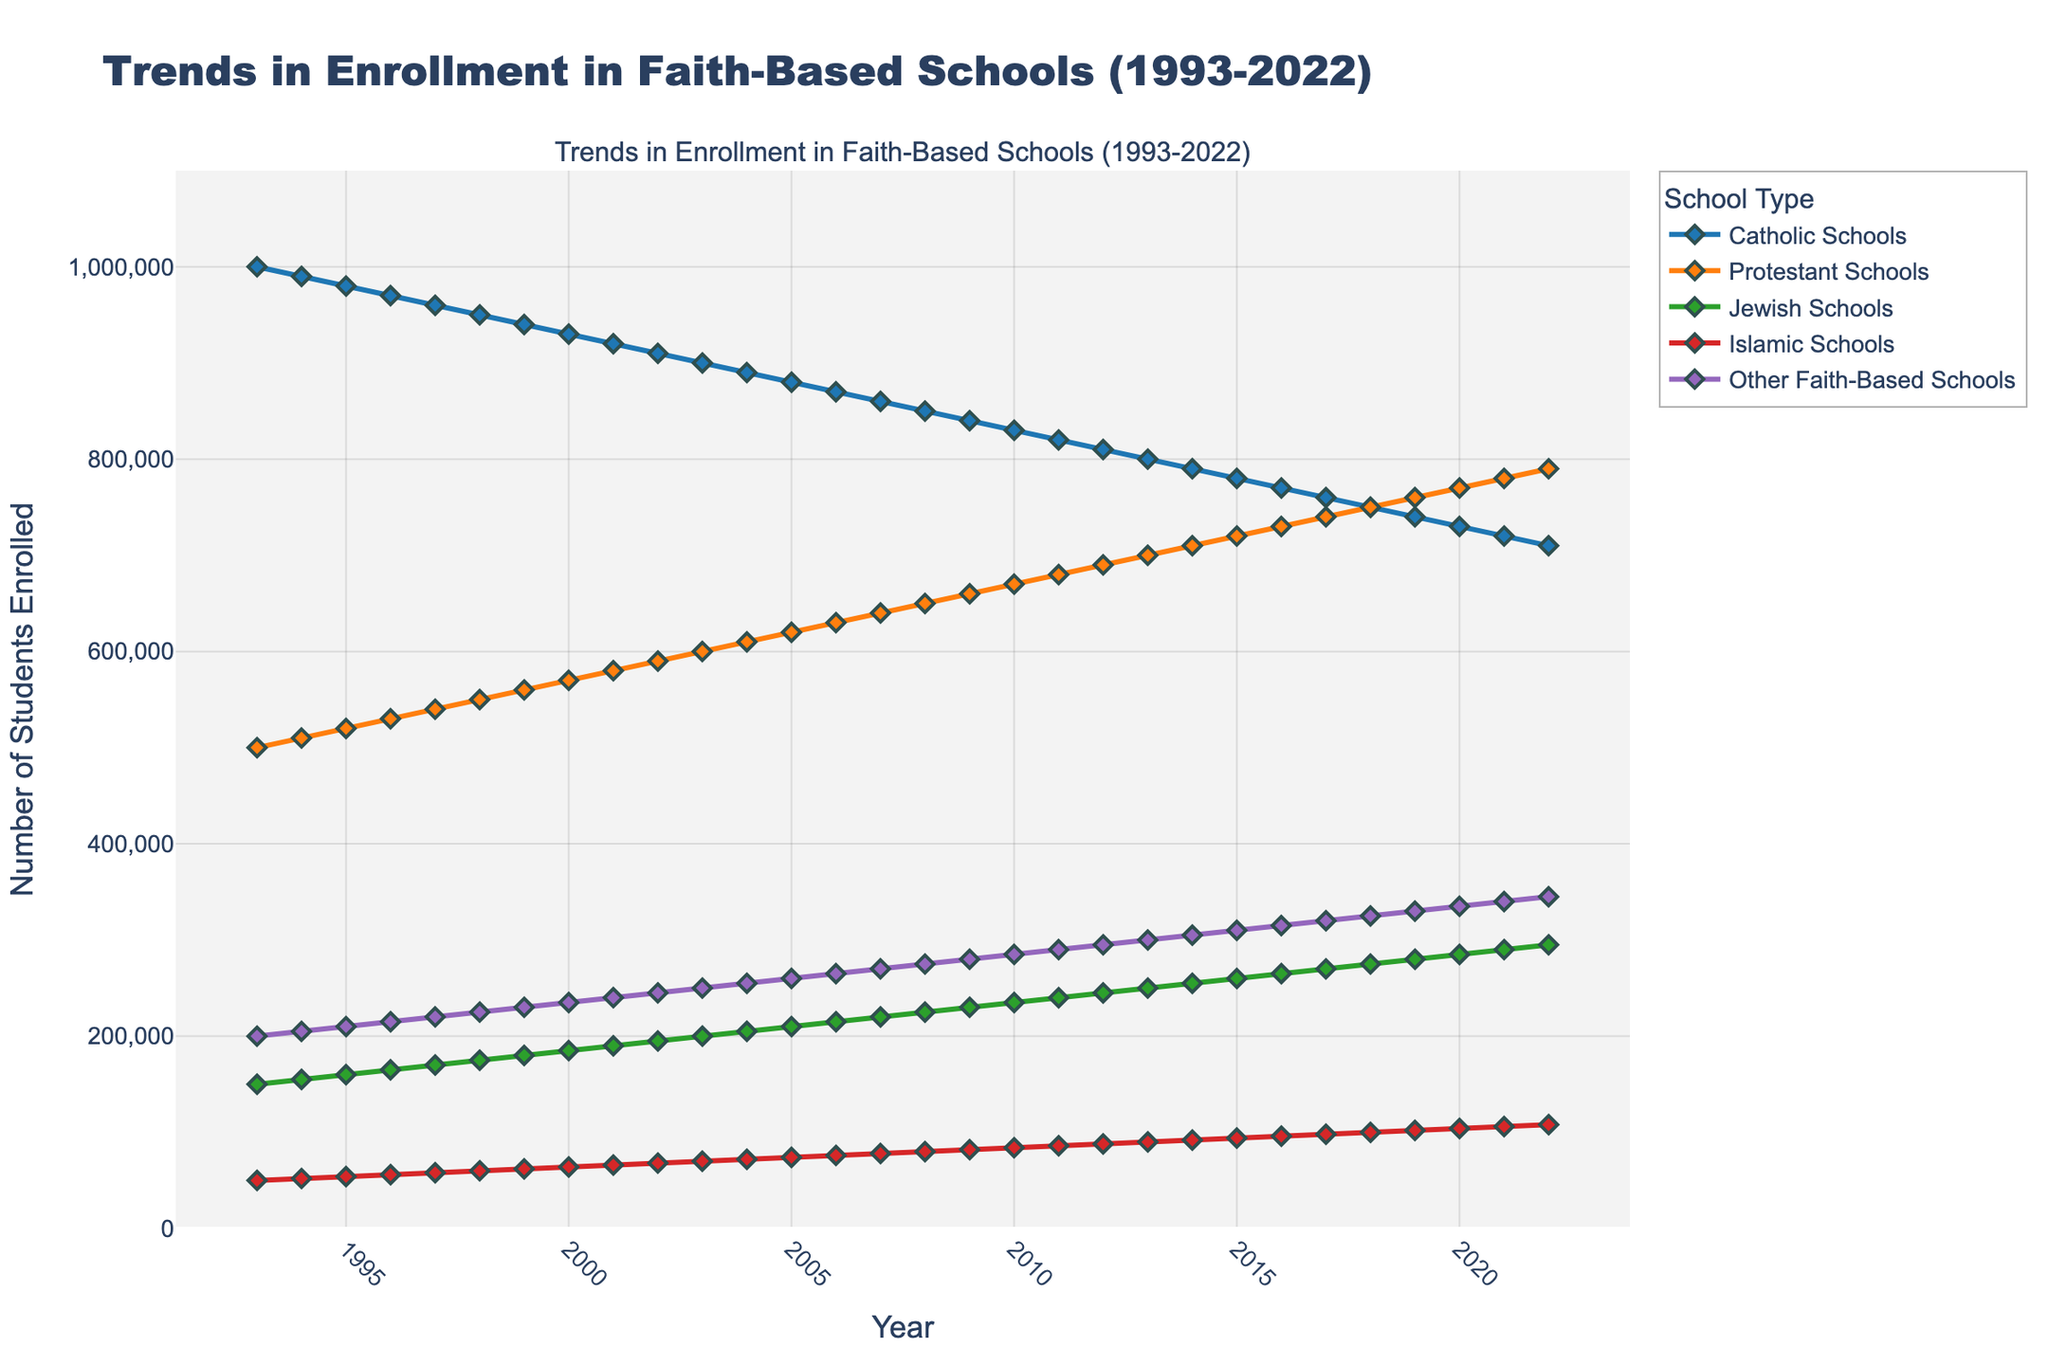what is the title of the plot? The title of a plot is typically located at the top center and is usually bold or larger in font. The title of this plot states "Trends in Enrollment in Faith-Based Schools (1993-2022)"
Answer: Trends in Enrollment in Faith-Based Schools (1993-2022) What is the enrollment trend for Catholic Schools from 1993 to 2022? To answer this, look at the line that represents Catholic Schools from the start year, 1993, to the end year, 2022. The line decreases, showing a decline in enrollment.
Answer: Decreasing trend Which faith-based school had the highest enrollment in 2022? To determine this, compare the enrollment figures for all faith-based schools in the year 2022. The line for Protestant Schools is at the highest point among others.
Answer: Protestant Schools How does the enrollment trend for Islamic Schools compare to Jewish Schools between 2000 and 2020? Compare the lines representing Islamic and Jewish Schools between 2000 and 2020. Islamic Schools' enrollment increased steadily, while Jewish Schools' enrollment also increased at a slower rate. Both show upward trends, but Islamic Schools had a steeper growth.
Answer: Islamic Schools increased more steeply What is the general trend in enrollment for "Other Faith-Based Schools" over the 30-year period? Observe the line for "Other Faith-Based Schools" from 1993 to 2022. The line shows a consistent increase, indicating a growing trend in enrollment over the 30-year span.
Answer: Increasing trend By how much did enrollment in Protestant Schools increase from 1993 to 2022? Find the Protestant Schools enrollment in 1993 and 2022, then calculate the difference. In 1993, it was 500,000, and in 2022, it was 790,000. Subtract 500,000 from 790,000.
Answer: 290,000 Which faith-based school type saw the most dramatic change in enrollment? Compare the slopes of all the lines. Protestant Schools show the steepest increase from 500,000 to 790,000, indicating the most dramatic change.
Answer: Protestant Schools Among all the faith-based school types, which one had the smallest total increase in enrollment over the 30 years? Calculate the difference between the 1993 and 2022 enrollments for each faith-based school type. Catholic Schools decreased the most from 1,000,000 to 710,000, a decrease rather than an increase.
Answer: Catholic Schools How did the enrollment in Jewish Schools change from 1993 to 2003? Look at the line for Jewish Schools between 1993 and 2003. Enrollment increased from 150,000 in 1993 to 200,000 in 2003.
Answer: Increased by 50,000 